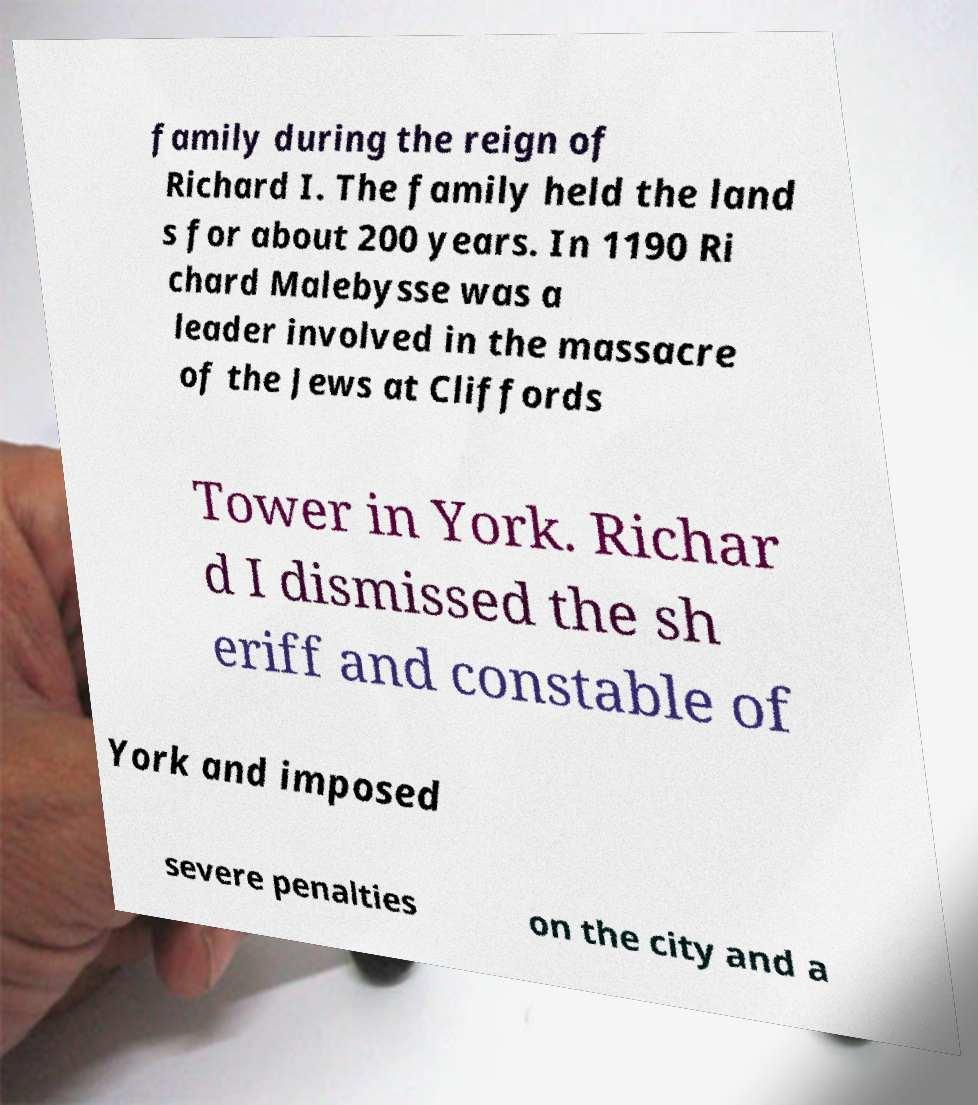There's text embedded in this image that I need extracted. Can you transcribe it verbatim? family during the reign of Richard I. The family held the land s for about 200 years. In 1190 Ri chard Malebysse was a leader involved in the massacre of the Jews at Cliffords Tower in York. Richar d I dismissed the sh eriff and constable of York and imposed severe penalties on the city and a 